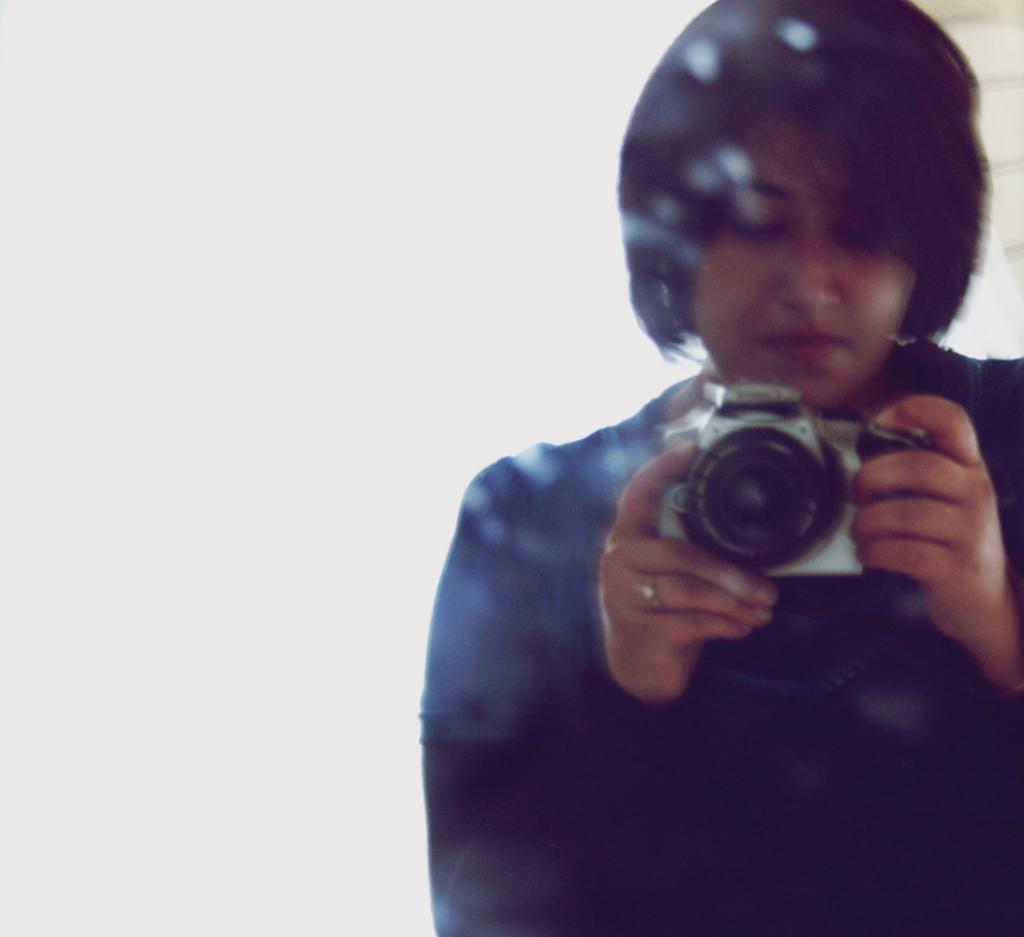Who is present in the image? There is a woman in the image. What is the woman wearing on her upper body? The woman is wearing a t-shirt. Are there any accessories visible on the woman? Yes, the woman is wearing a ring. What is the woman holding in the image? The woman is holding a camera. What can be seen in the background of the image? There is a wall visible in the image. What type of cabbage can be seen growing on the wall in the image? There is no cabbage visible in the image; only a wall is present in the background. 